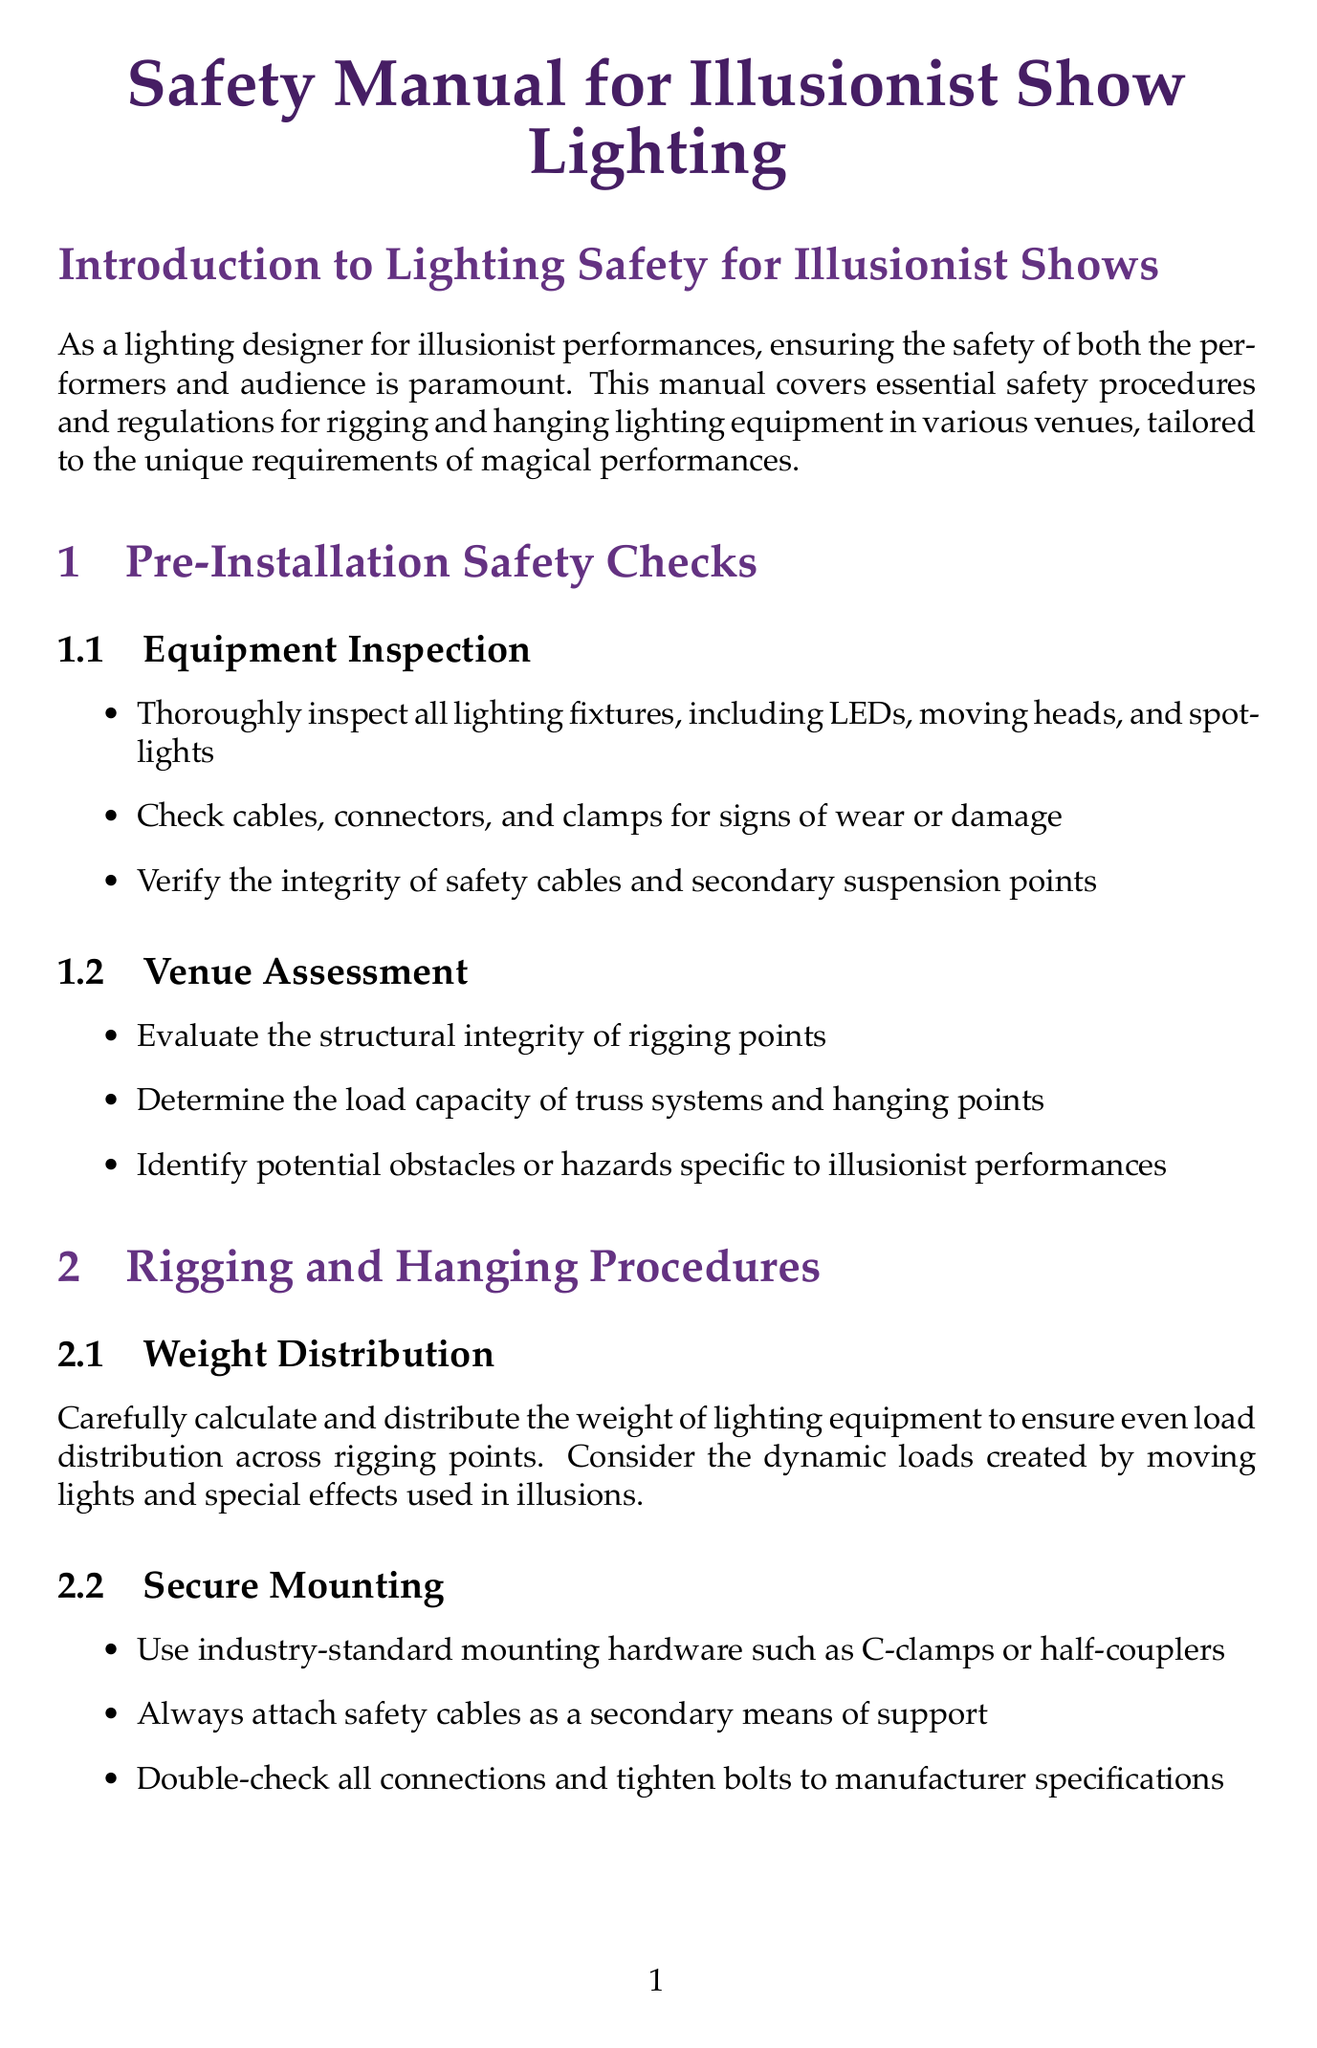What does the manual primarily cover? The manual covers essential safety procedures and regulations for rigging and hanging lighting equipment in various venues, specifically for illusionist performances.
Answer: safety procedures and regulations for rigging and hanging lighting equipment What is one type of personal protective equipment mentioned? The document lists multiple items of personal protective equipment (PPE), and one of them is a hard hat.
Answer: hard hat How often should comprehensive inspections be conducted? The document states that routine maintenance should include comprehensive inspections every month.
Answer: monthly What protocol is indicated for equipment failure? The document outlines a protocol that includes ceasing operations and evacuating the area.
Answer: Equipment Failure Protocol Which organization's standards does the manual suggest familiarizing with? The manual recommends familiarizing oneself primarily with ANSI E1.21 standards.
Answer: ANSI E1.21 What should be checked during the venue assessment? During the venue assessment, the structural integrity of rigging points must be evaluated.
Answer: structural integrity of rigging points How should weight distribution be managed? Weight distribution should be carefully calculated and distributed to ensure even load distribution across rigging points.
Answer: evenly distributed across rigging points What is a specific safety feature mentioned for illusionist tricks? The document suggests using DMX-controlled blackout features as a safety measure.
Answer: DMX-controlled blackout features 